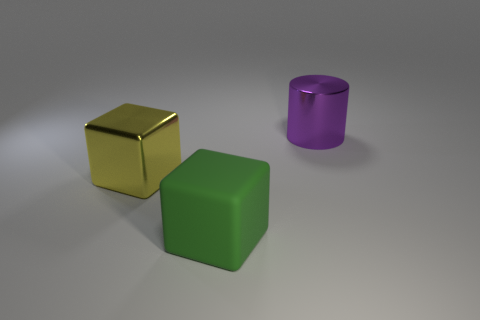There is a object that is to the right of the green block; does it have the same color as the big metallic block?
Offer a very short reply. No. How many other things are there of the same color as the big rubber thing?
Provide a short and direct response. 0. What number of small things are brown shiny cubes or metal cylinders?
Provide a succinct answer. 0. Is the number of green matte blocks greater than the number of small green shiny cubes?
Give a very brief answer. Yes. Do the green cube and the big yellow cube have the same material?
Provide a succinct answer. No. Are there any other things that are the same material as the green thing?
Provide a short and direct response. No. Are there more yellow things that are in front of the large purple metal thing than purple balls?
Your answer should be compact. Yes. How many green matte objects are the same shape as the yellow thing?
Your answer should be compact. 1. There is a block that is the same material as the big cylinder; what size is it?
Offer a very short reply. Large. There is a thing that is both behind the green matte cube and to the left of the purple thing; what is its color?
Make the answer very short. Yellow. 